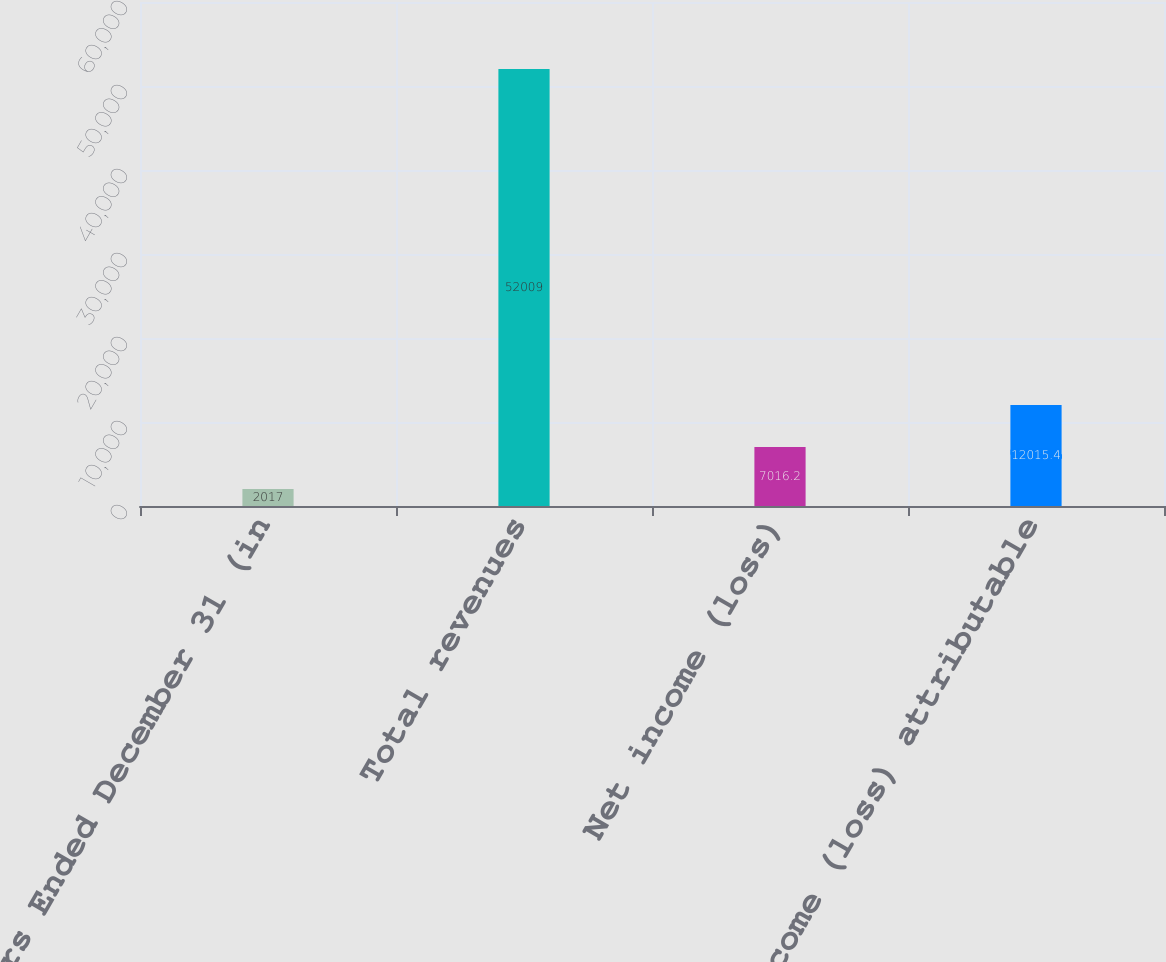Convert chart to OTSL. <chart><loc_0><loc_0><loc_500><loc_500><bar_chart><fcel>Years Ended December 31 (in<fcel>Total revenues<fcel>Net income (loss)<fcel>Net income (loss) attributable<nl><fcel>2017<fcel>52009<fcel>7016.2<fcel>12015.4<nl></chart> 